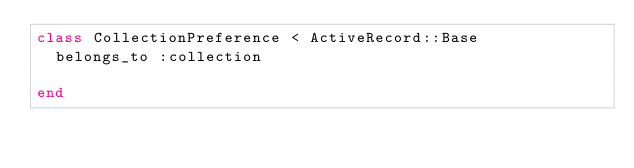Convert code to text. <code><loc_0><loc_0><loc_500><loc_500><_Ruby_>class CollectionPreference < ActiveRecord::Base
  belongs_to :collection
  
end
</code> 